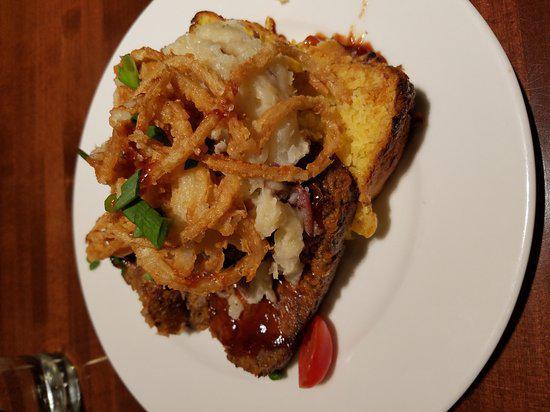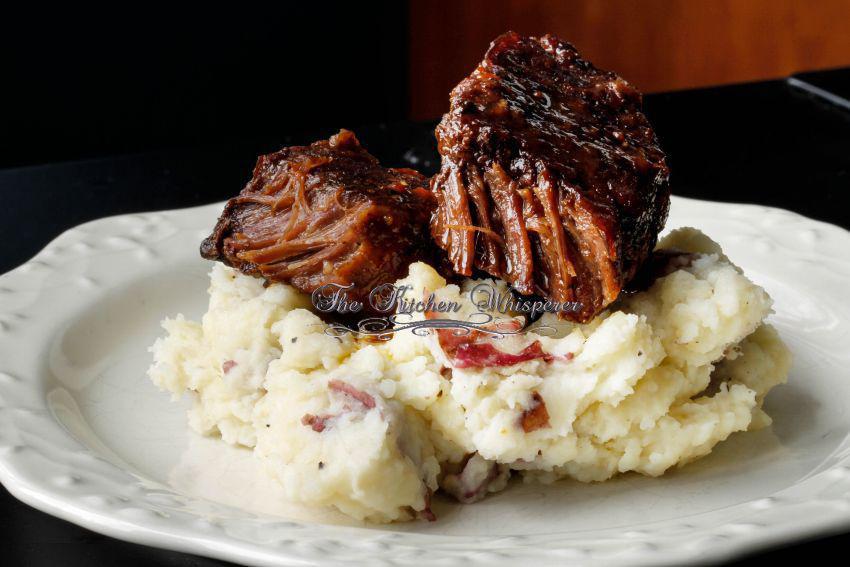The first image is the image on the left, the second image is the image on the right. Assess this claim about the two images: "The right dish is entirely layered, the left dish has a green vegetable.". Correct or not? Answer yes or no. No. The first image is the image on the left, the second image is the image on the right. For the images shown, is this caption "A serving of cooked green vegetables is on a plate next to some type of prepared meat." true? Answer yes or no. No. 